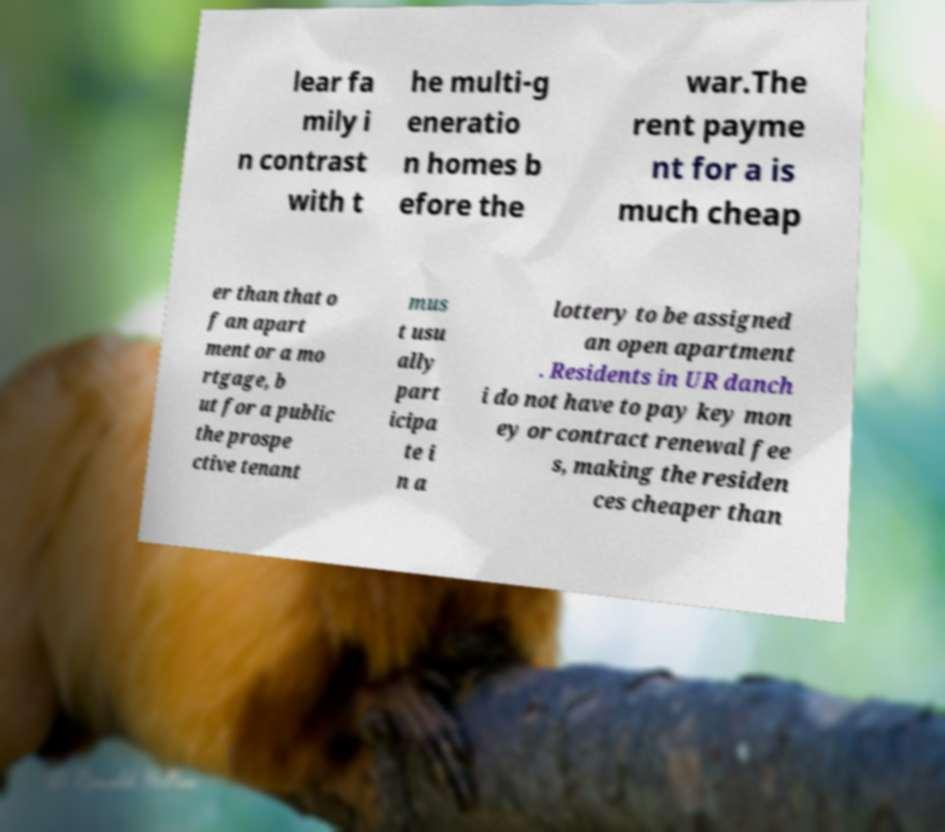What messages or text are displayed in this image? I need them in a readable, typed format. lear fa mily i n contrast with t he multi-g eneratio n homes b efore the war.The rent payme nt for a is much cheap er than that o f an apart ment or a mo rtgage, b ut for a public the prospe ctive tenant mus t usu ally part icipa te i n a lottery to be assigned an open apartment . Residents in UR danch i do not have to pay key mon ey or contract renewal fee s, making the residen ces cheaper than 